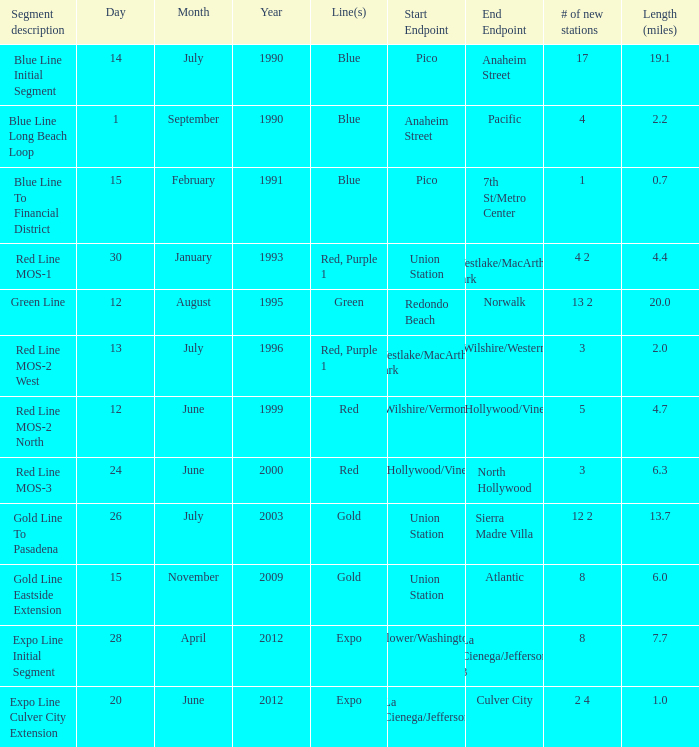What is the length  (miles) when pico to 7th st/metro center are the endpoints? 0.7. 